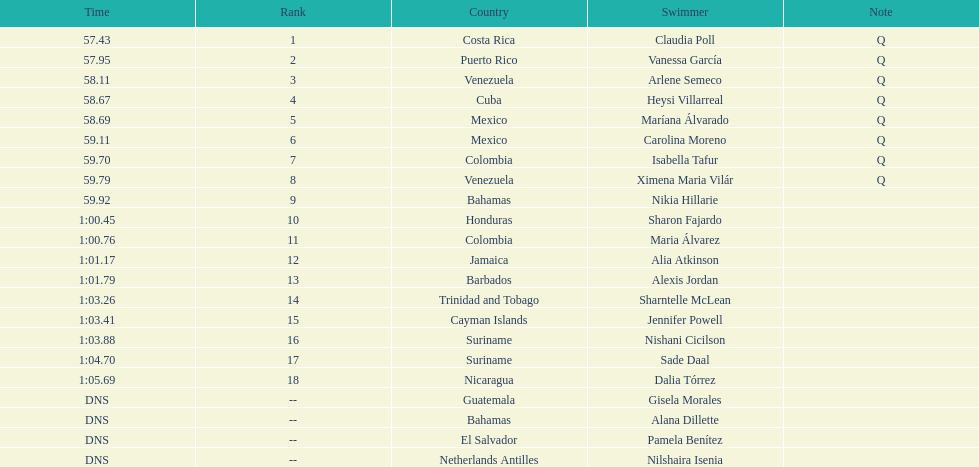How many swimmers had a time of at least 1:00 9. 